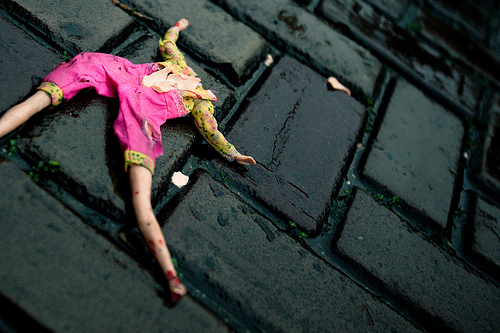<image>
Is there a brick above the doll? No. The brick is not positioned above the doll. The vertical arrangement shows a different relationship. Where is the no head in relation to the ground? Is it on the ground? Yes. Looking at the image, I can see the no head is positioned on top of the ground, with the ground providing support. 